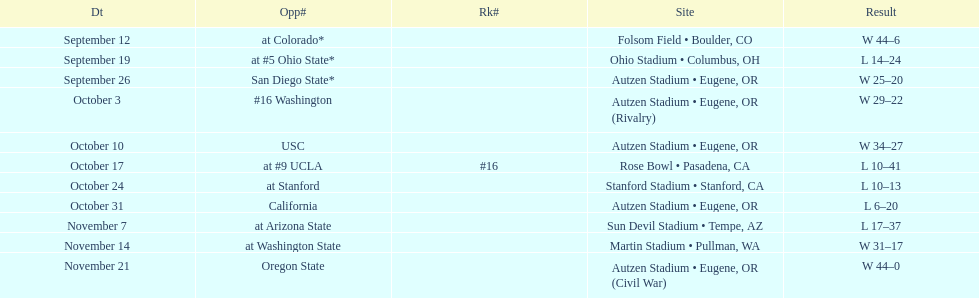Were the results of the game of november 14 above or below the results of the october 17 game? Above. 